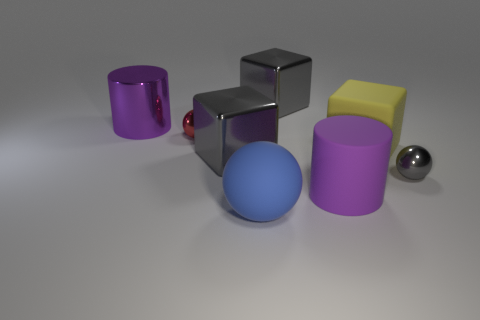Add 2 shiny balls. How many objects exist? 10 Subtract all blocks. How many objects are left? 5 Subtract all large objects. Subtract all large purple shiny things. How many objects are left? 1 Add 5 blue rubber objects. How many blue rubber objects are left? 6 Add 3 metal blocks. How many metal blocks exist? 5 Subtract 0 cyan spheres. How many objects are left? 8 